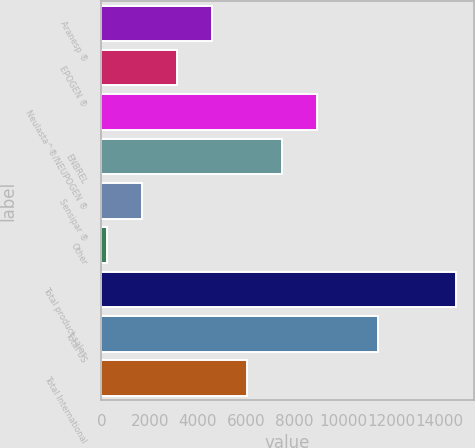<chart> <loc_0><loc_0><loc_500><loc_500><bar_chart><fcel>Aranesp ®<fcel>EPOGEN ®<fcel>Neulasta^®/NEUPOGEN ®<fcel>ENBREL<fcel>Sensipar ®<fcel>Other<fcel>Total product sales<fcel>Total US<fcel>Total International<nl><fcel>4574.1<fcel>3129.4<fcel>8908.2<fcel>7463.5<fcel>1684.7<fcel>240<fcel>14687<fcel>11460<fcel>6018.8<nl></chart> 